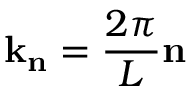Convert formula to latex. <formula><loc_0><loc_0><loc_500><loc_500>k _ { n } = \frac { 2 \pi } { L } n</formula> 